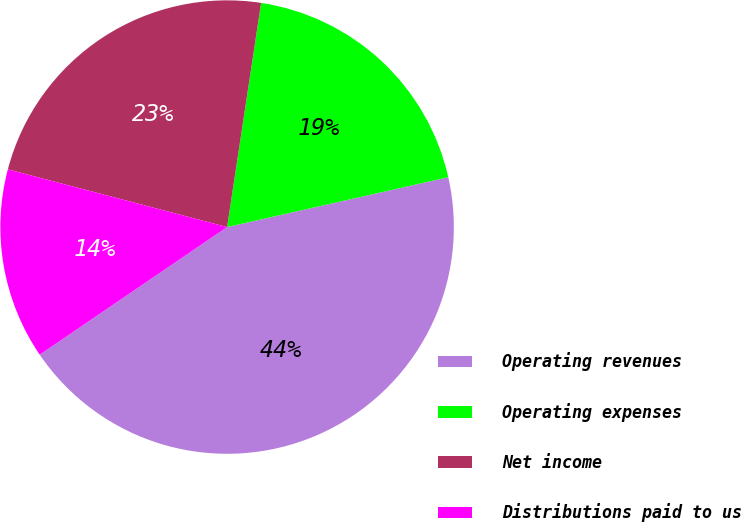<chart> <loc_0><loc_0><loc_500><loc_500><pie_chart><fcel>Operating revenues<fcel>Operating expenses<fcel>Net income<fcel>Distributions paid to us<nl><fcel>44.01%<fcel>19.07%<fcel>23.3%<fcel>13.61%<nl></chart> 